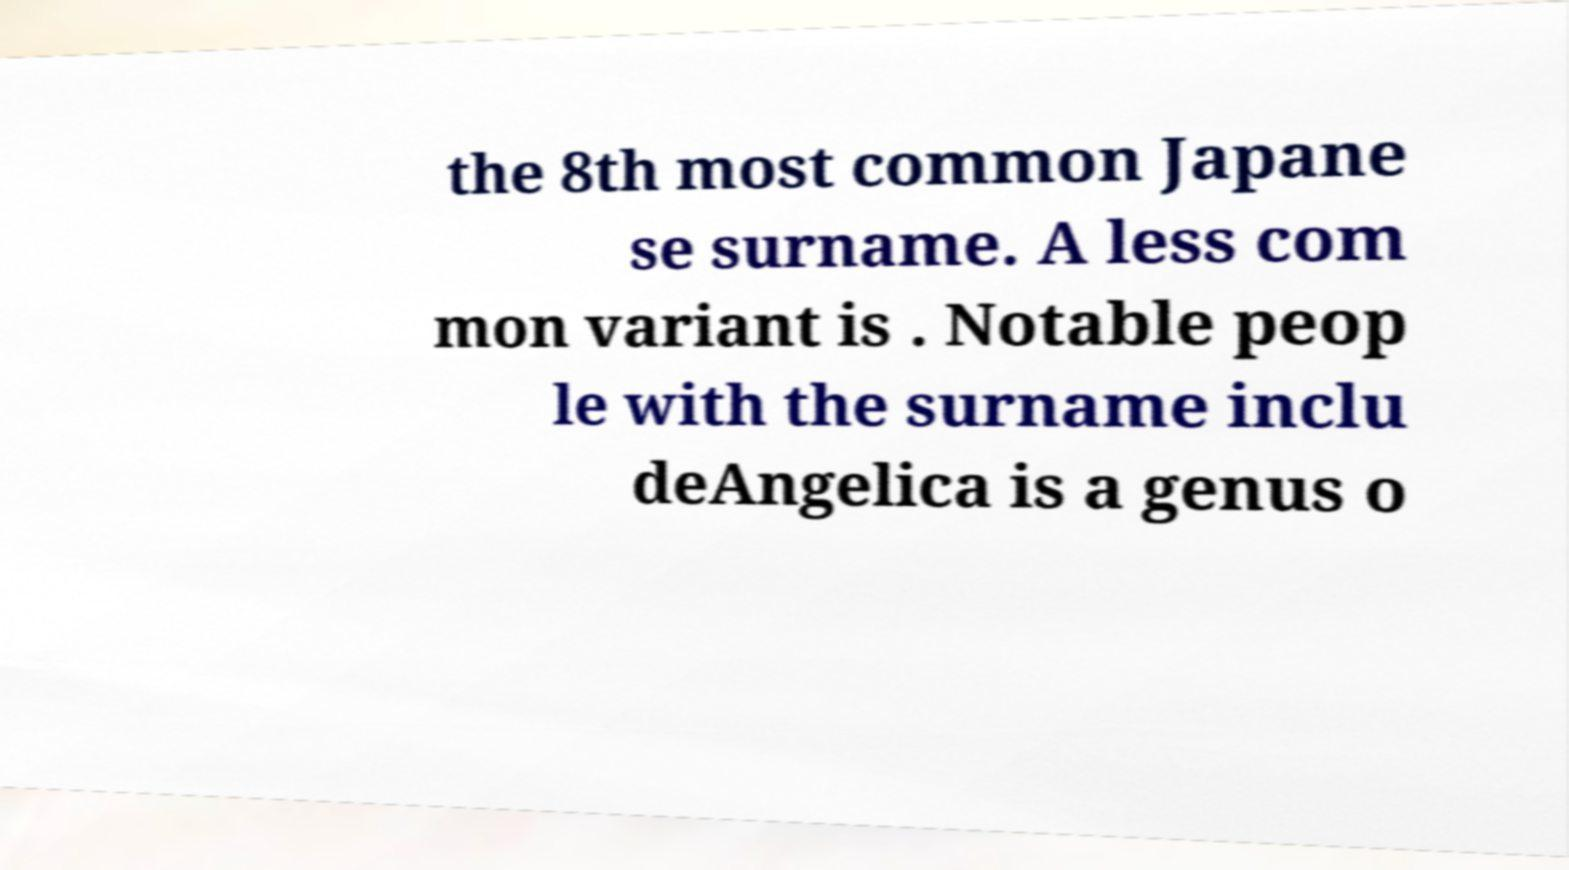Could you extract and type out the text from this image? the 8th most common Japane se surname. A less com mon variant is . Notable peop le with the surname inclu deAngelica is a genus o 